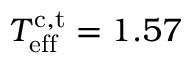<formula> <loc_0><loc_0><loc_500><loc_500>T _ { e f f } ^ { c , t } = 1 . 5 7</formula> 